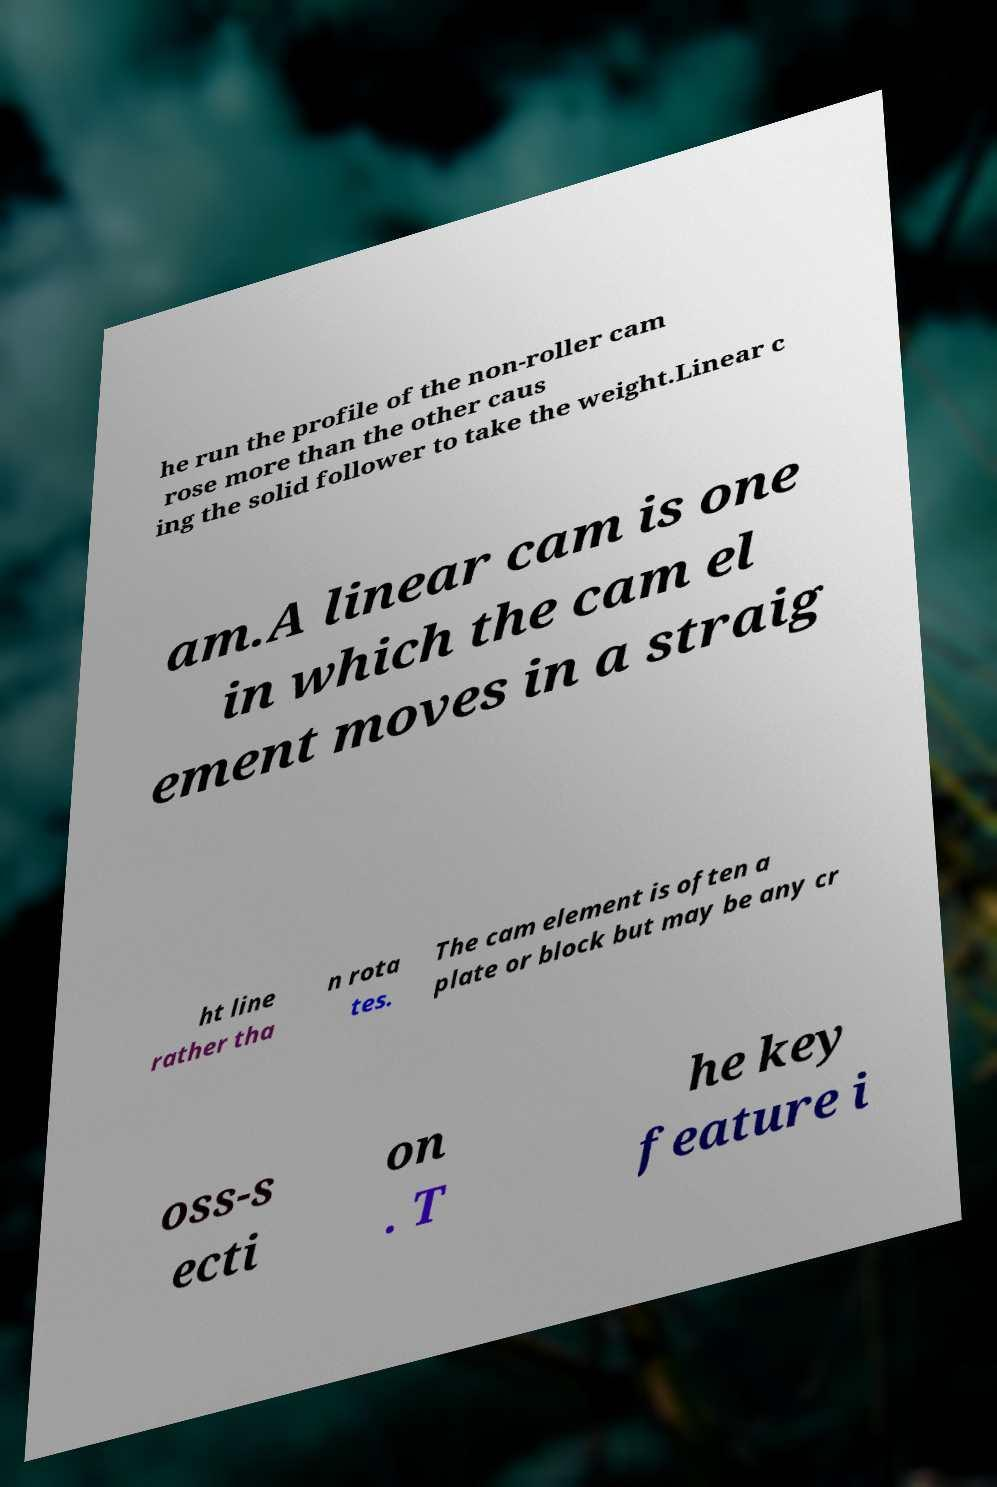For documentation purposes, I need the text within this image transcribed. Could you provide that? he run the profile of the non-roller cam rose more than the other caus ing the solid follower to take the weight.Linear c am.A linear cam is one in which the cam el ement moves in a straig ht line rather tha n rota tes. The cam element is often a plate or block but may be any cr oss-s ecti on . T he key feature i 